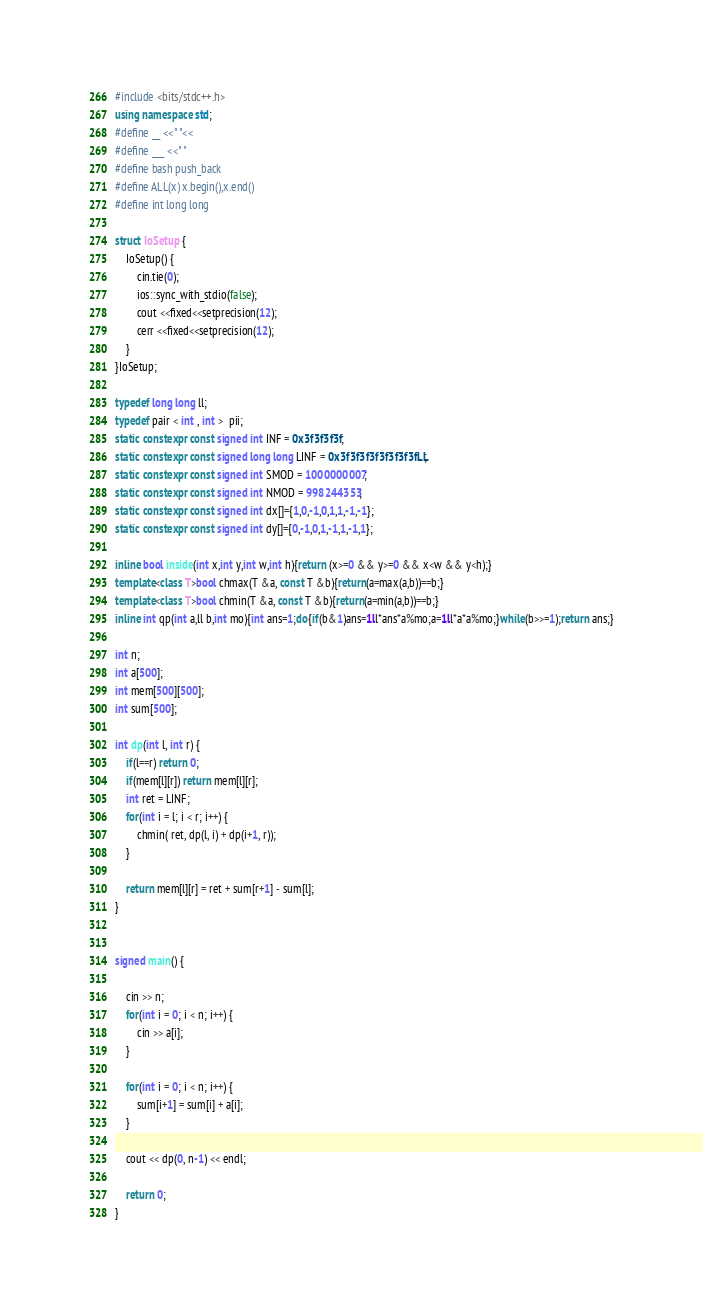<code> <loc_0><loc_0><loc_500><loc_500><_C++_>#include <bits/stdc++.h>
using namespace std;
#define __ <<" "<<
#define ___ <<" "
#define bash push_back
#define ALL(x) x.begin(),x.end()
#define int long long

struct IoSetup {
    IoSetup() {
        cin.tie(0);
        ios::sync_with_stdio(false);
        cout <<fixed<<setprecision(12);
        cerr <<fixed<<setprecision(12);
    }
}IoSetup;

typedef long long ll;
typedef pair < int , int >  pii;
static constexpr const signed int INF = 0x3f3f3f3f;
static constexpr const signed long long LINF = 0x3f3f3f3f3f3f3f3fLL;
static constexpr const signed int SMOD = 1000000007;
static constexpr const signed int NMOD = 998244353;
static constexpr const signed int dx[]={1,0,-1,0,1,1,-1,-1};
static constexpr const signed int dy[]={0,-1,0,1,-1,1,-1,1};

inline bool inside(int x,int y,int w,int h){return (x>=0 && y>=0 && x<w && y<h);}
template<class T>bool chmax(T &a, const T &b){return(a=max(a,b))==b;}
template<class T>bool chmin(T &a, const T &b){return(a=min(a,b))==b;}
inline int qp(int a,ll b,int mo){int ans=1;do{if(b&1)ans=1ll*ans*a%mo;a=1ll*a*a%mo;}while(b>>=1);return ans;}

int n;
int a[500];
int mem[500][500];
int sum[500];

int dp(int l, int r) {
    if(l==r) return 0;
    if(mem[l][r]) return mem[l][r];
    int ret = LINF;
    for(int i = l; i < r; i++) {
        chmin( ret, dp(l, i) + dp(i+1, r));
    }
    
    return mem[l][r] = ret + sum[r+1] - sum[l];
}


signed main() {

    cin >> n;
    for(int i = 0; i < n; i++) {
        cin >> a[i];
    }

    for(int i = 0; i < n; i++) {
        sum[i+1] = sum[i] + a[i];
    }
    
    cout << dp(0, n-1) << endl;
  
    return 0;
}

</code> 